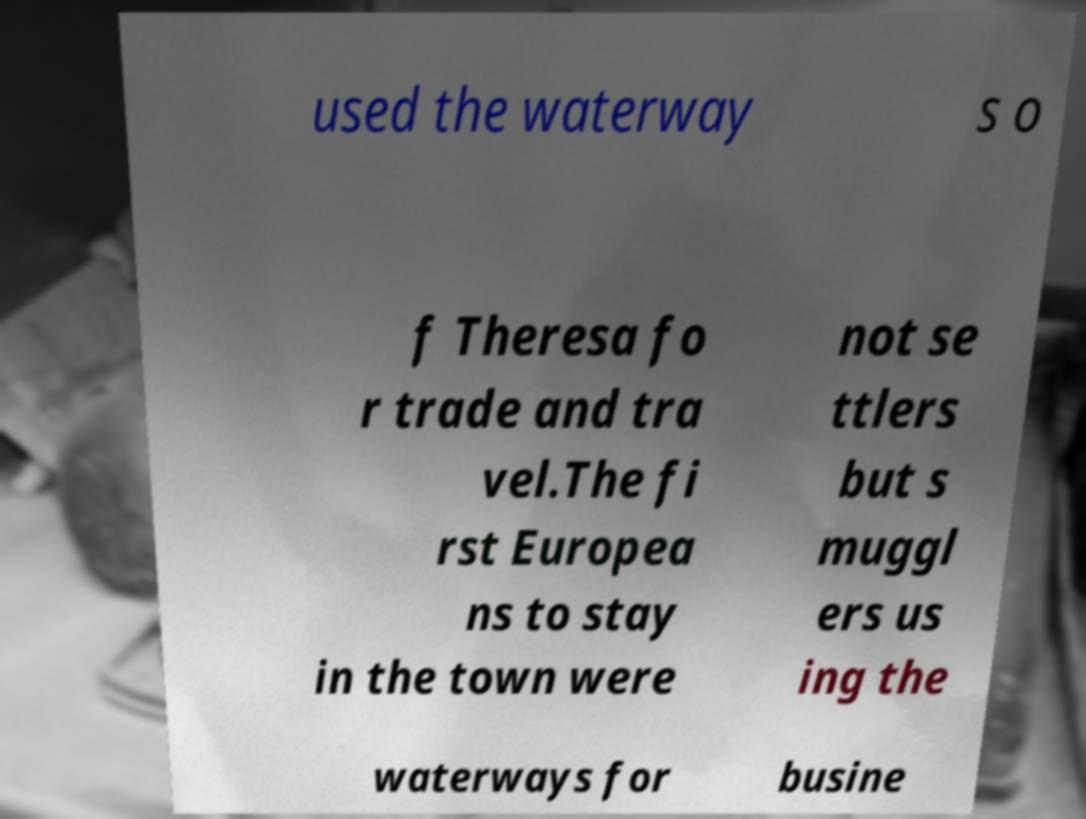I need the written content from this picture converted into text. Can you do that? used the waterway s o f Theresa fo r trade and tra vel.The fi rst Europea ns to stay in the town were not se ttlers but s muggl ers us ing the waterways for busine 